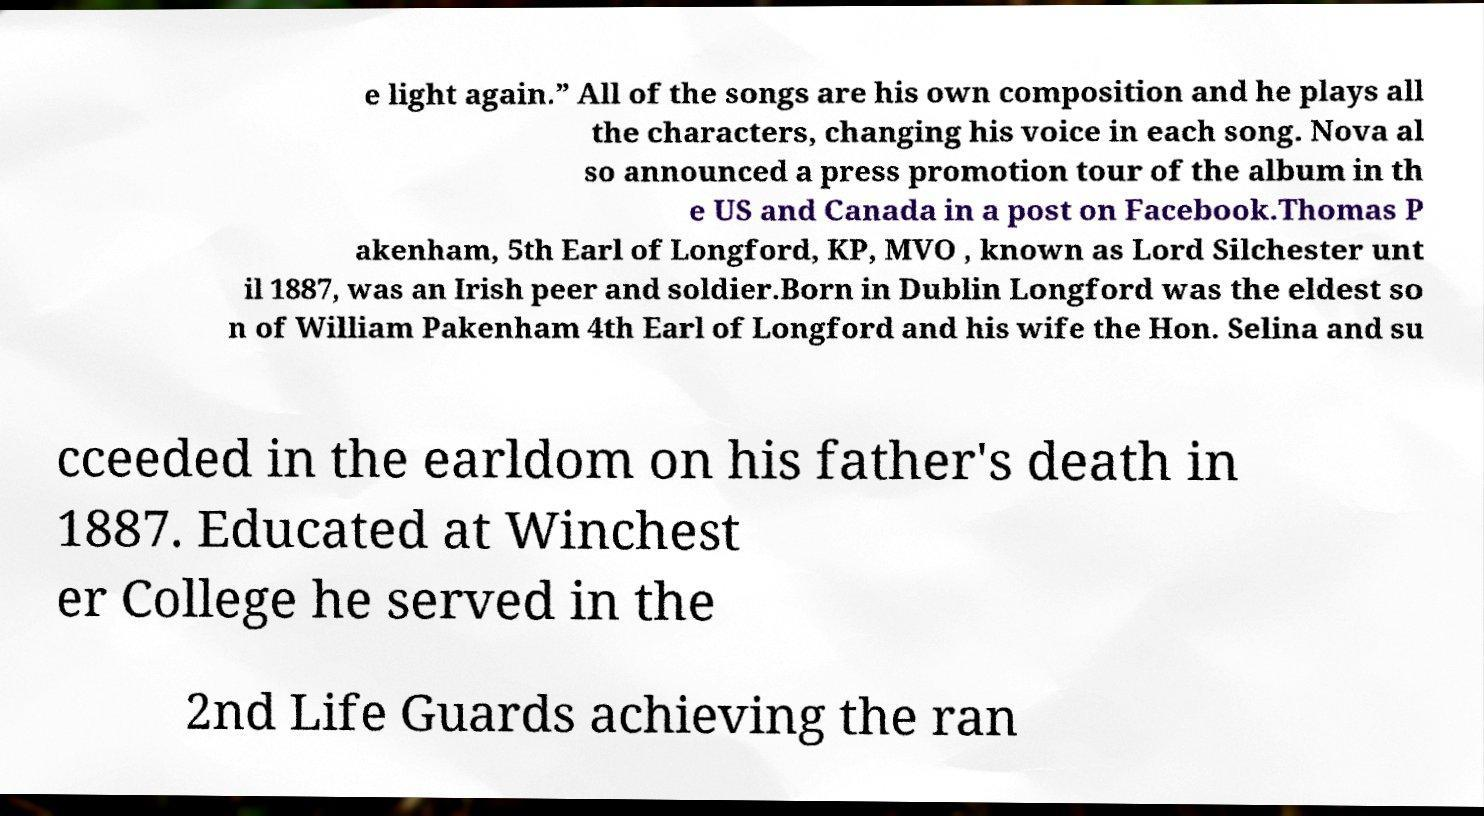Can you read and provide the text displayed in the image?This photo seems to have some interesting text. Can you extract and type it out for me? e light again.” All of the songs are his own composition and he plays all the characters, changing his voice in each song. Nova al so announced a press promotion tour of the album in th e US and Canada in a post on Facebook.Thomas P akenham, 5th Earl of Longford, KP, MVO , known as Lord Silchester unt il 1887, was an Irish peer and soldier.Born in Dublin Longford was the eldest so n of William Pakenham 4th Earl of Longford and his wife the Hon. Selina and su cceeded in the earldom on his father's death in 1887. Educated at Winchest er College he served in the 2nd Life Guards achieving the ran 